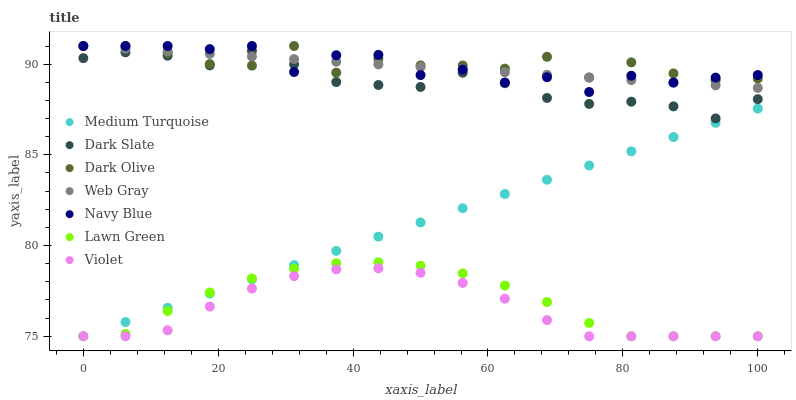Does Violet have the minimum area under the curve?
Answer yes or no. Yes. Does Dark Olive have the maximum area under the curve?
Answer yes or no. Yes. Does Web Gray have the minimum area under the curve?
Answer yes or no. No. Does Web Gray have the maximum area under the curve?
Answer yes or no. No. Is Medium Turquoise the smoothest?
Answer yes or no. Yes. Is Dark Olive the roughest?
Answer yes or no. Yes. Is Web Gray the smoothest?
Answer yes or no. No. Is Web Gray the roughest?
Answer yes or no. No. Does Lawn Green have the lowest value?
Answer yes or no. Yes. Does Web Gray have the lowest value?
Answer yes or no. No. Does Dark Olive have the highest value?
Answer yes or no. Yes. Does Dark Slate have the highest value?
Answer yes or no. No. Is Medium Turquoise less than Web Gray?
Answer yes or no. Yes. Is Web Gray greater than Medium Turquoise?
Answer yes or no. Yes. Does Navy Blue intersect Dark Olive?
Answer yes or no. Yes. Is Navy Blue less than Dark Olive?
Answer yes or no. No. Is Navy Blue greater than Dark Olive?
Answer yes or no. No. Does Medium Turquoise intersect Web Gray?
Answer yes or no. No. 